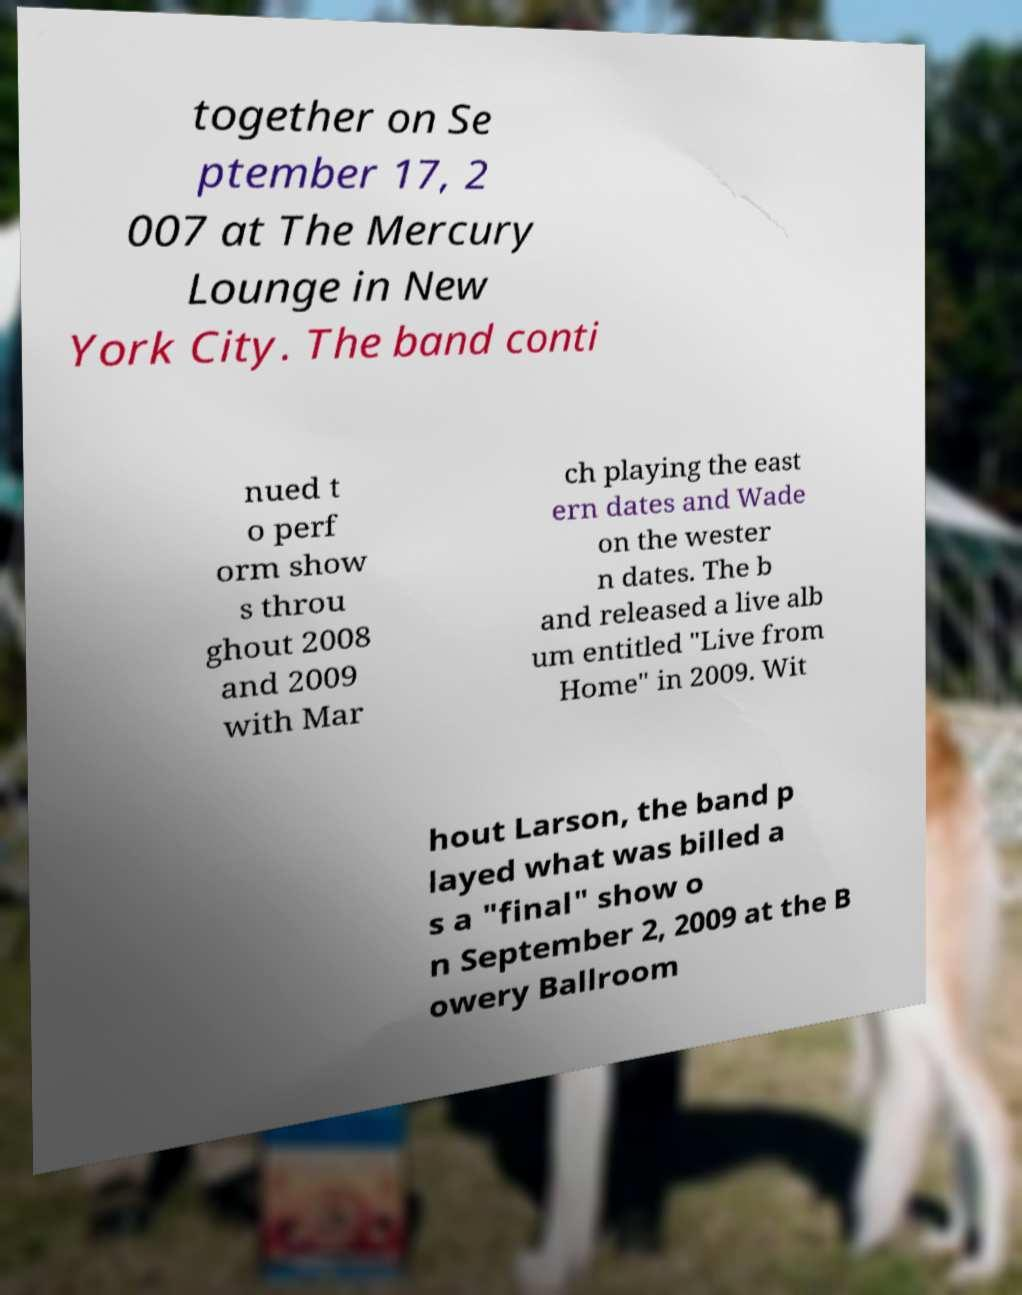What messages or text are displayed in this image? I need them in a readable, typed format. together on Se ptember 17, 2 007 at The Mercury Lounge in New York City. The band conti nued t o perf orm show s throu ghout 2008 and 2009 with Mar ch playing the east ern dates and Wade on the wester n dates. The b and released a live alb um entitled "Live from Home" in 2009. Wit hout Larson, the band p layed what was billed a s a "final" show o n September 2, 2009 at the B owery Ballroom 